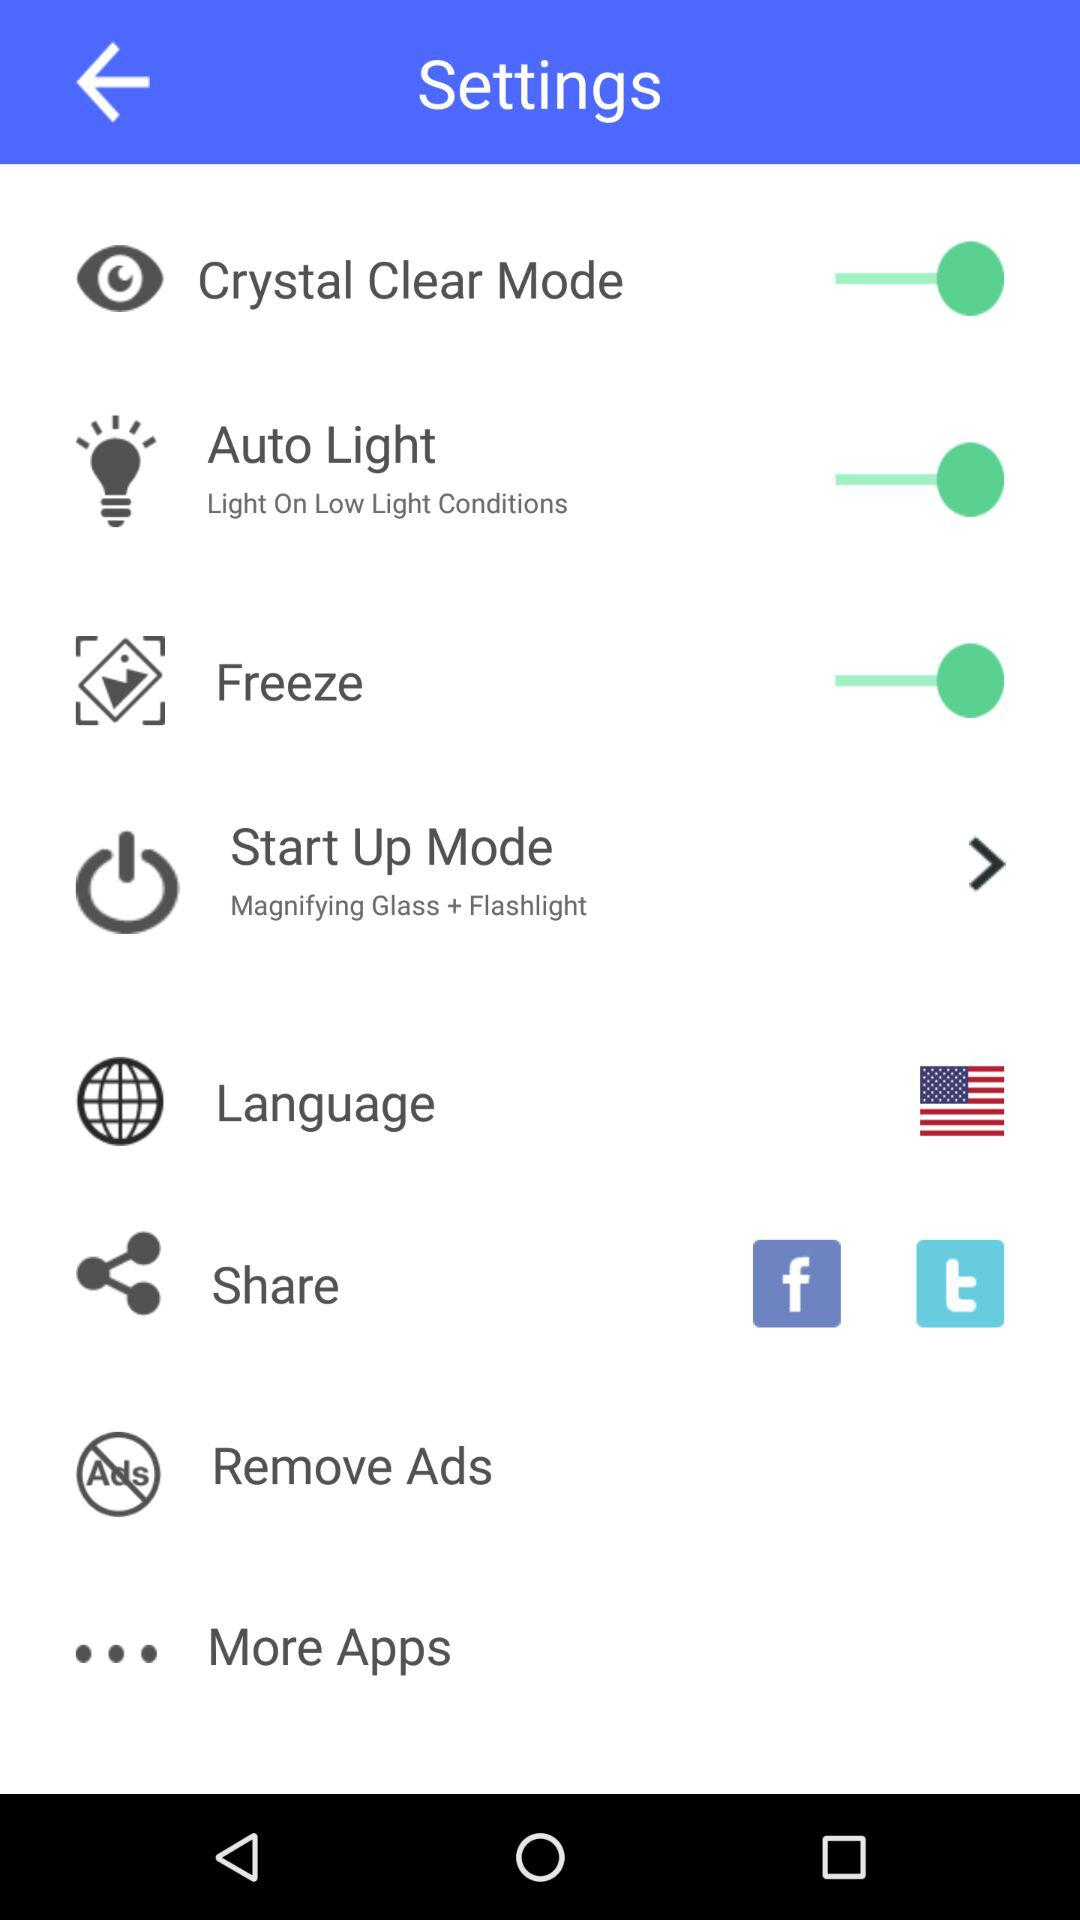How many items have the switch element?
Answer the question using a single word or phrase. 3 